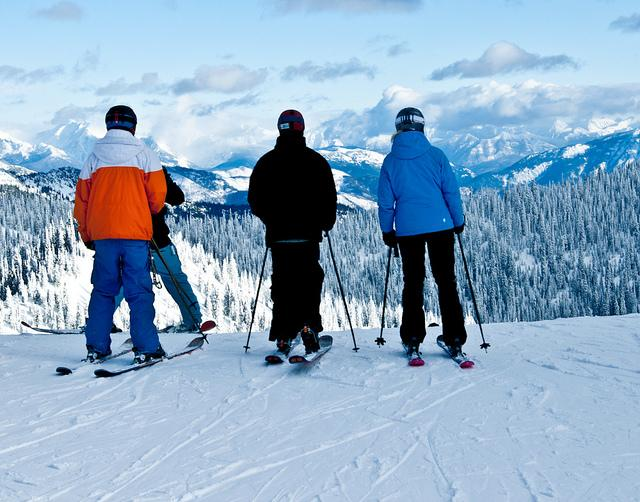What are the people surrounded by? Please explain your reasoning. snow. The frozen precipitation will allow them to glide faster down the mountain. 